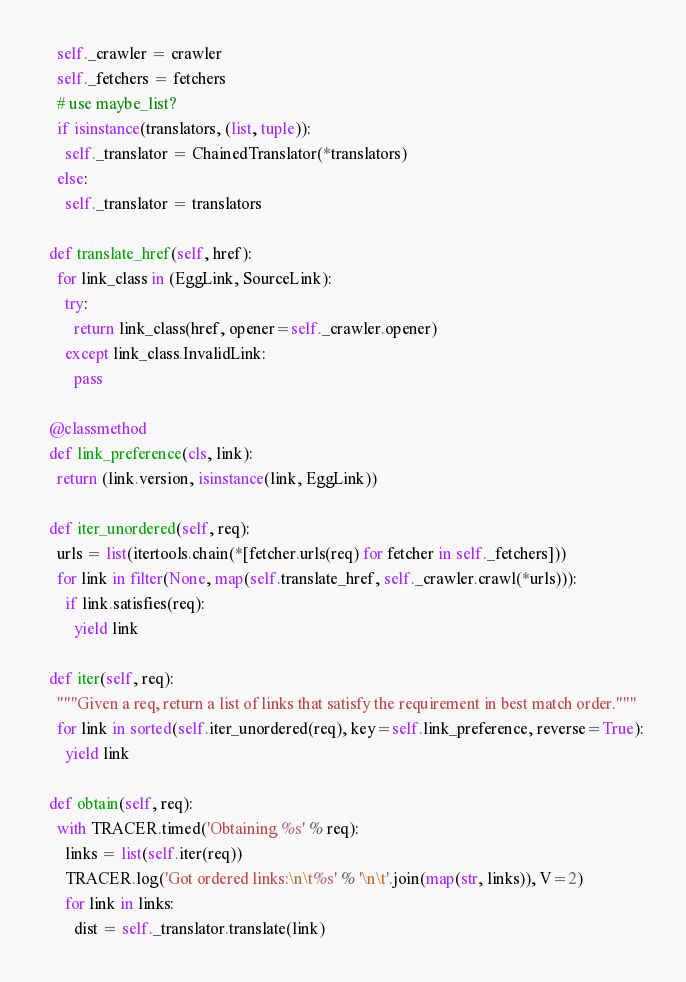<code> <loc_0><loc_0><loc_500><loc_500><_Python_>    self._crawler = crawler
    self._fetchers = fetchers
    # use maybe_list?
    if isinstance(translators, (list, tuple)):
      self._translator = ChainedTranslator(*translators)
    else:
      self._translator = translators

  def translate_href(self, href):
    for link_class in (EggLink, SourceLink):
      try:
        return link_class(href, opener=self._crawler.opener)
      except link_class.InvalidLink:
        pass

  @classmethod
  def link_preference(cls, link):
    return (link.version, isinstance(link, EggLink))

  def iter_unordered(self, req):
    urls = list(itertools.chain(*[fetcher.urls(req) for fetcher in self._fetchers]))
    for link in filter(None, map(self.translate_href, self._crawler.crawl(*urls))):
      if link.satisfies(req):
        yield link

  def iter(self, req):
    """Given a req, return a list of links that satisfy the requirement in best match order."""
    for link in sorted(self.iter_unordered(req), key=self.link_preference, reverse=True):
      yield link

  def obtain(self, req):
    with TRACER.timed('Obtaining %s' % req):
      links = list(self.iter(req))
      TRACER.log('Got ordered links:\n\t%s' % '\n\t'.join(map(str, links)), V=2)
      for link in links:
        dist = self._translator.translate(link)</code> 